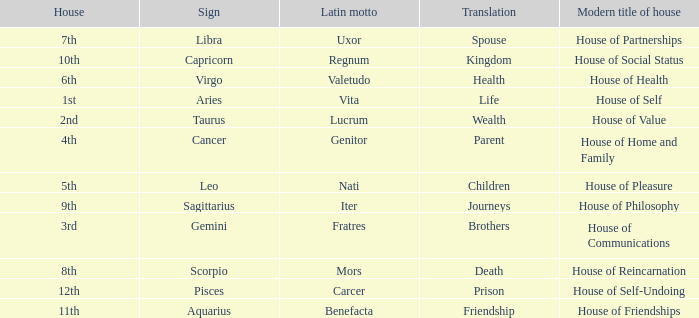What is the translation of the sign of Aquarius? Friendship. 